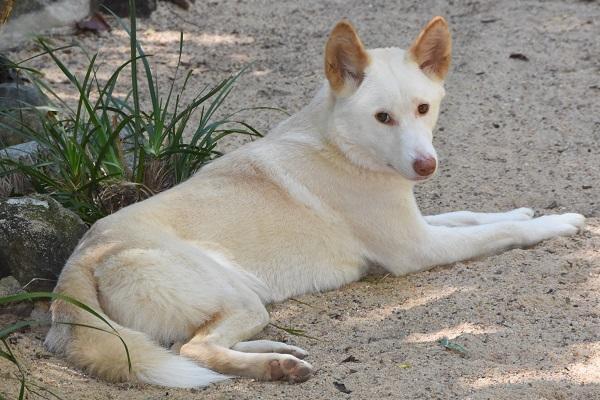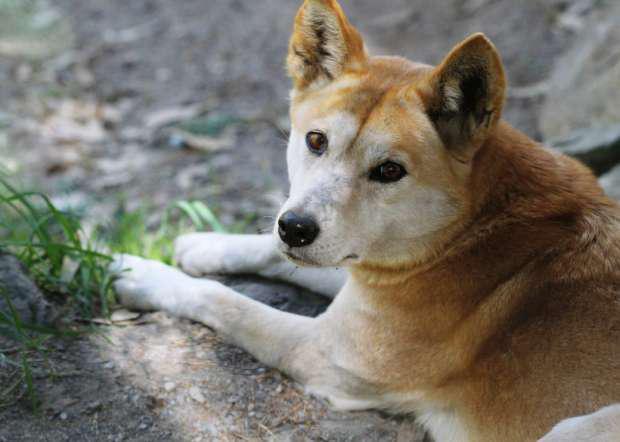The first image is the image on the left, the second image is the image on the right. For the images displayed, is the sentence "Atleast one image of a dog sitting or laying down." factually correct? Answer yes or no. Yes. The first image is the image on the left, the second image is the image on the right. For the images shown, is this caption "Each image contains a single dingo, and one is in an upright sitting pose, while the other is standing on all fours." true? Answer yes or no. No. 